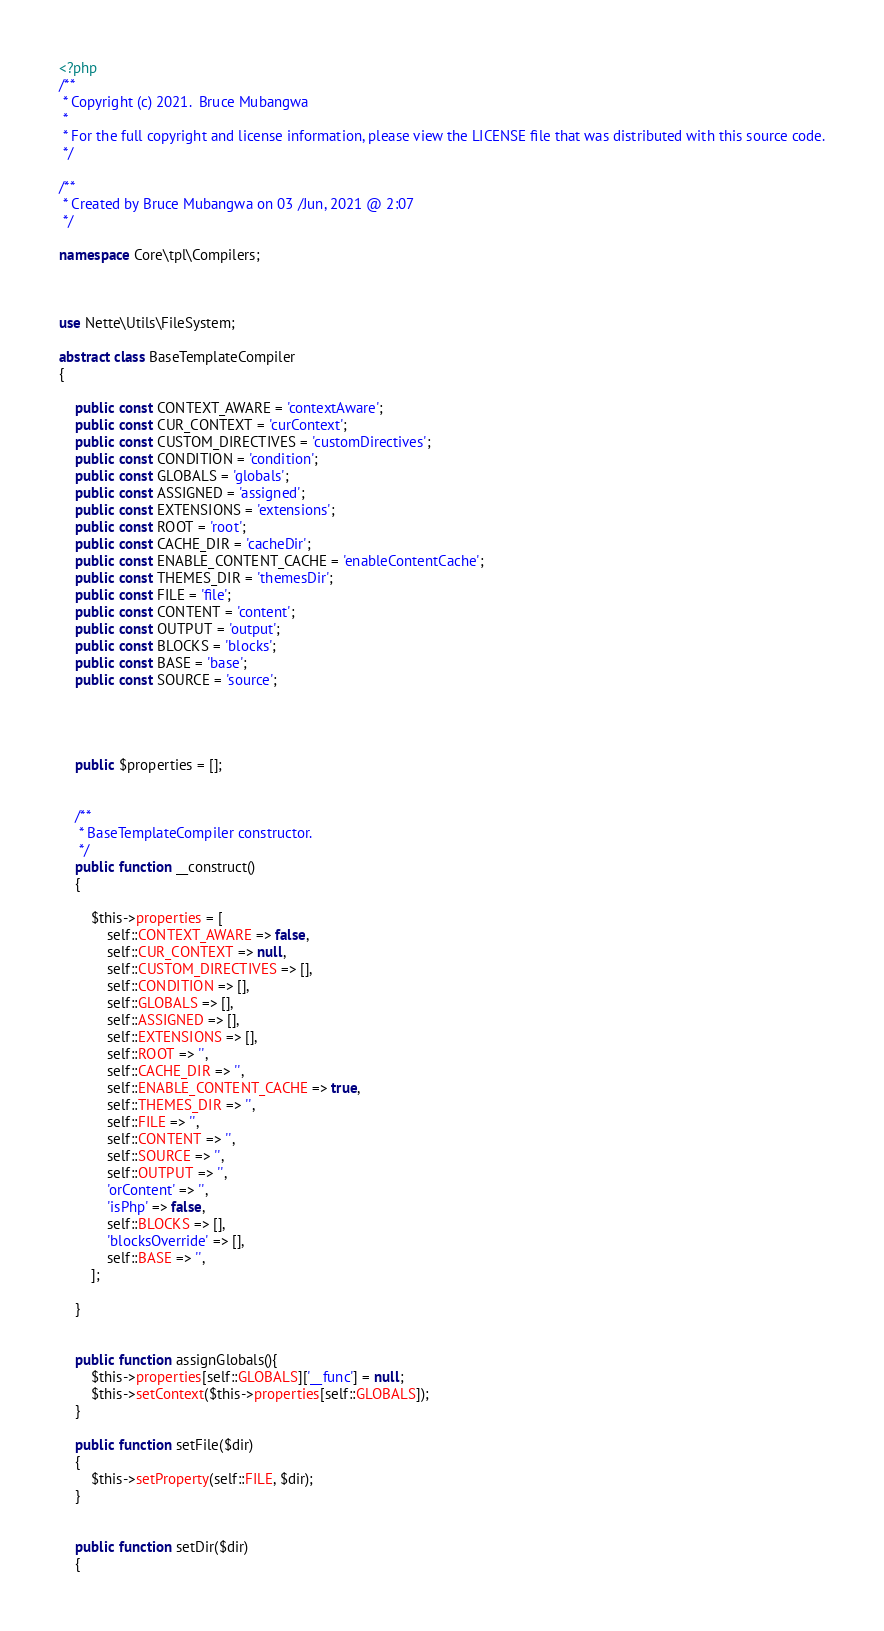Convert code to text. <code><loc_0><loc_0><loc_500><loc_500><_PHP_><?php
/**
 * Copyright (c) 2021.  Bruce Mubangwa
 *
 * For the full copyright and license information, please view the LICENSE file that was distributed with this source code.
 */

/**
 * Created by Bruce Mubangwa on 03 /Jun, 2021 @ 2:07
 */

namespace Core\tpl\Compilers;



use Nette\Utils\FileSystem;

abstract class BaseTemplateCompiler
{

    public const CONTEXT_AWARE = 'contextAware';
    public const CUR_CONTEXT = 'curContext';
    public const CUSTOM_DIRECTIVES = 'customDirectives';
    public const CONDITION = 'condition';
    public const GLOBALS = 'globals';
    public const ASSIGNED = 'assigned';
    public const EXTENSIONS = 'extensions';
    public const ROOT = 'root';
    public const CACHE_DIR = 'cacheDir';
    public const ENABLE_CONTENT_CACHE = 'enableContentCache';
    public const THEMES_DIR = 'themesDir';
    public const FILE = 'file';
    public const CONTENT = 'content';
    public const OUTPUT = 'output';
    public const BLOCKS = 'blocks';
    public const BASE = 'base';
    public const SOURCE = 'source';




    public $properties = [];


    /**
     * BaseTemplateCompiler constructor.
     */
    public function __construct()
    {

        $this->properties = [
            self::CONTEXT_AWARE => false,
            self::CUR_CONTEXT => null,
            self::CUSTOM_DIRECTIVES => [],
            self::CONDITION => [],
            self::GLOBALS => [],
            self::ASSIGNED => [],
            self::EXTENSIONS => [],
            self::ROOT => '',
            self::CACHE_DIR => '',
            self::ENABLE_CONTENT_CACHE => true,
            self::THEMES_DIR => '',
            self::FILE => '',
            self::CONTENT => '',
            self::SOURCE => '',
            self::OUTPUT => '',
            'orContent' => '',
            'isPhp' => false,
            self::BLOCKS => [],
            'blocksOverride' => [],
            self::BASE => '',
        ];

    }


    public function assignGlobals(){
        $this->properties[self::GLOBALS]['__func'] = null;
        $this->setContext($this->properties[self::GLOBALS]);
    }

    public function setFile($dir)
    {
        $this->setProperty(self::FILE, $dir);
    }


    public function setDir($dir)
    {</code> 